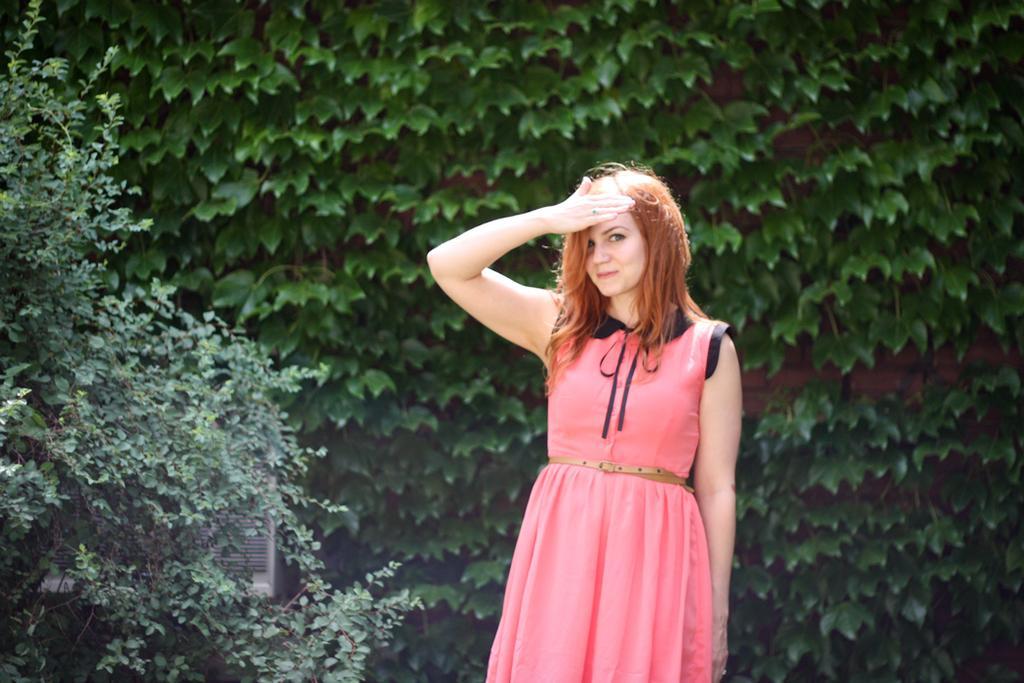In one or two sentences, can you explain what this image depicts? Here in this picture we can see a woman standing on the ground over there and she is wearing pink colored dress on her and smiling and behind her we can see plants and trees present all over there. 